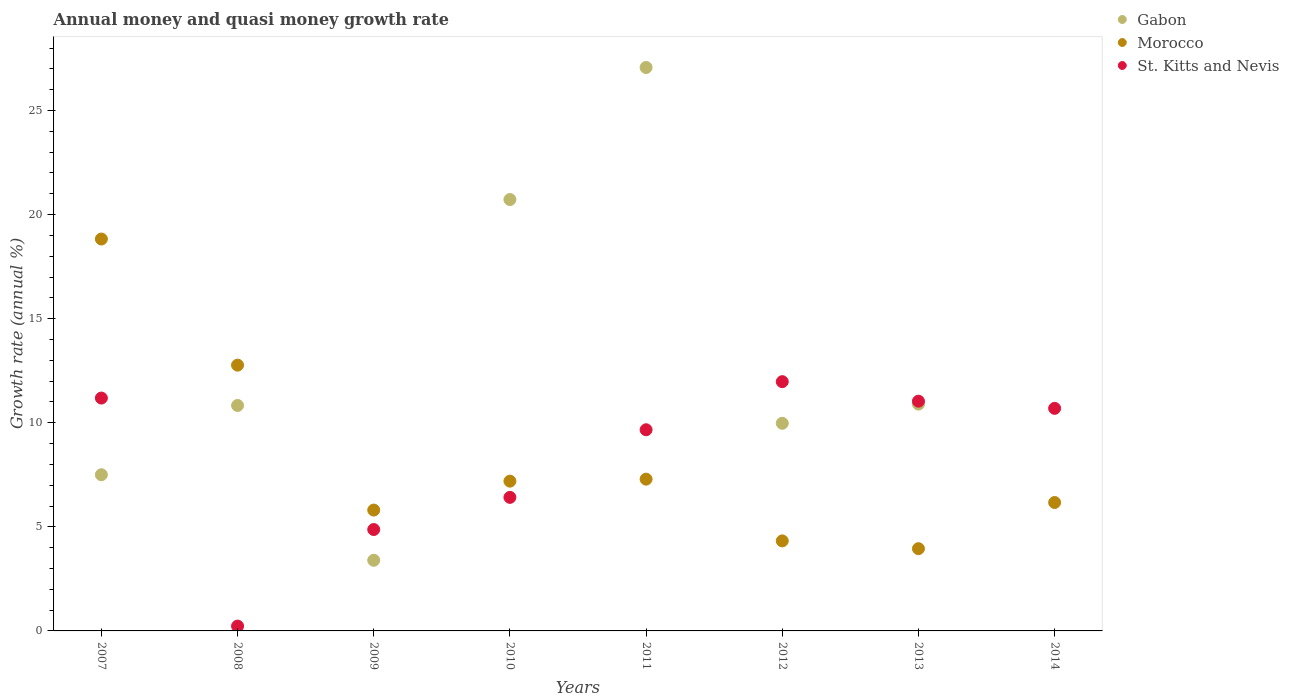How many different coloured dotlines are there?
Give a very brief answer. 3. What is the growth rate in St. Kitts and Nevis in 2014?
Make the answer very short. 10.69. Across all years, what is the maximum growth rate in Gabon?
Provide a short and direct response. 27.07. Across all years, what is the minimum growth rate in St. Kitts and Nevis?
Offer a very short reply. 0.23. What is the total growth rate in Gabon in the graph?
Offer a very short reply. 90.38. What is the difference between the growth rate in Morocco in 2011 and that in 2014?
Provide a short and direct response. 1.12. What is the difference between the growth rate in Gabon in 2013 and the growth rate in Morocco in 2007?
Offer a very short reply. -7.93. What is the average growth rate in Morocco per year?
Keep it short and to the point. 8.29. In the year 2012, what is the difference between the growth rate in Morocco and growth rate in Gabon?
Provide a short and direct response. -5.65. What is the ratio of the growth rate in Morocco in 2010 to that in 2011?
Keep it short and to the point. 0.99. Is the growth rate in Gabon in 2008 less than that in 2009?
Offer a very short reply. No. Is the difference between the growth rate in Morocco in 2012 and 2013 greater than the difference between the growth rate in Gabon in 2012 and 2013?
Provide a succinct answer. Yes. What is the difference between the highest and the second highest growth rate in Gabon?
Ensure brevity in your answer.  6.34. What is the difference between the highest and the lowest growth rate in Morocco?
Keep it short and to the point. 14.87. Is the sum of the growth rate in Gabon in 2008 and 2010 greater than the maximum growth rate in St. Kitts and Nevis across all years?
Offer a terse response. Yes. Is it the case that in every year, the sum of the growth rate in Gabon and growth rate in Morocco  is greater than the growth rate in St. Kitts and Nevis?
Provide a succinct answer. No. Does the growth rate in St. Kitts and Nevis monotonically increase over the years?
Provide a succinct answer. No. Is the growth rate in St. Kitts and Nevis strictly greater than the growth rate in Morocco over the years?
Ensure brevity in your answer.  No. Is the growth rate in St. Kitts and Nevis strictly less than the growth rate in Gabon over the years?
Your answer should be compact. No. How many dotlines are there?
Your answer should be very brief. 3. How many years are there in the graph?
Your answer should be very brief. 8. Are the values on the major ticks of Y-axis written in scientific E-notation?
Keep it short and to the point. No. How many legend labels are there?
Offer a terse response. 3. How are the legend labels stacked?
Ensure brevity in your answer.  Vertical. What is the title of the graph?
Ensure brevity in your answer.  Annual money and quasi money growth rate. Does "Croatia" appear as one of the legend labels in the graph?
Offer a very short reply. No. What is the label or title of the X-axis?
Offer a terse response. Years. What is the label or title of the Y-axis?
Keep it short and to the point. Growth rate (annual %). What is the Growth rate (annual %) in Gabon in 2007?
Provide a short and direct response. 7.5. What is the Growth rate (annual %) in Morocco in 2007?
Offer a terse response. 18.83. What is the Growth rate (annual %) of St. Kitts and Nevis in 2007?
Give a very brief answer. 11.19. What is the Growth rate (annual %) of Gabon in 2008?
Give a very brief answer. 10.83. What is the Growth rate (annual %) in Morocco in 2008?
Your response must be concise. 12.77. What is the Growth rate (annual %) in St. Kitts and Nevis in 2008?
Provide a short and direct response. 0.23. What is the Growth rate (annual %) of Gabon in 2009?
Offer a very short reply. 3.39. What is the Growth rate (annual %) of Morocco in 2009?
Make the answer very short. 5.8. What is the Growth rate (annual %) of St. Kitts and Nevis in 2009?
Provide a succinct answer. 4.87. What is the Growth rate (annual %) of Gabon in 2010?
Keep it short and to the point. 20.72. What is the Growth rate (annual %) of Morocco in 2010?
Your answer should be compact. 7.19. What is the Growth rate (annual %) in St. Kitts and Nevis in 2010?
Give a very brief answer. 6.41. What is the Growth rate (annual %) in Gabon in 2011?
Keep it short and to the point. 27.07. What is the Growth rate (annual %) of Morocco in 2011?
Provide a succinct answer. 7.29. What is the Growth rate (annual %) of St. Kitts and Nevis in 2011?
Your answer should be very brief. 9.66. What is the Growth rate (annual %) of Gabon in 2012?
Your answer should be compact. 9.97. What is the Growth rate (annual %) of Morocco in 2012?
Give a very brief answer. 4.32. What is the Growth rate (annual %) of St. Kitts and Nevis in 2012?
Your answer should be compact. 11.97. What is the Growth rate (annual %) in Gabon in 2013?
Make the answer very short. 10.9. What is the Growth rate (annual %) of Morocco in 2013?
Ensure brevity in your answer.  3.95. What is the Growth rate (annual %) of St. Kitts and Nevis in 2013?
Offer a very short reply. 11.04. What is the Growth rate (annual %) in Morocco in 2014?
Provide a succinct answer. 6.17. What is the Growth rate (annual %) in St. Kitts and Nevis in 2014?
Your answer should be compact. 10.69. Across all years, what is the maximum Growth rate (annual %) of Gabon?
Provide a short and direct response. 27.07. Across all years, what is the maximum Growth rate (annual %) of Morocco?
Ensure brevity in your answer.  18.83. Across all years, what is the maximum Growth rate (annual %) of St. Kitts and Nevis?
Keep it short and to the point. 11.97. Across all years, what is the minimum Growth rate (annual %) in Gabon?
Provide a succinct answer. 0. Across all years, what is the minimum Growth rate (annual %) in Morocco?
Offer a terse response. 3.95. Across all years, what is the minimum Growth rate (annual %) in St. Kitts and Nevis?
Your answer should be very brief. 0.23. What is the total Growth rate (annual %) of Gabon in the graph?
Offer a terse response. 90.38. What is the total Growth rate (annual %) of Morocco in the graph?
Your answer should be compact. 66.33. What is the total Growth rate (annual %) of St. Kitts and Nevis in the graph?
Provide a succinct answer. 66.07. What is the difference between the Growth rate (annual %) of Gabon in 2007 and that in 2008?
Your answer should be very brief. -3.33. What is the difference between the Growth rate (annual %) in Morocco in 2007 and that in 2008?
Keep it short and to the point. 6.06. What is the difference between the Growth rate (annual %) in St. Kitts and Nevis in 2007 and that in 2008?
Your response must be concise. 10.95. What is the difference between the Growth rate (annual %) in Gabon in 2007 and that in 2009?
Your answer should be very brief. 4.11. What is the difference between the Growth rate (annual %) in Morocco in 2007 and that in 2009?
Provide a succinct answer. 13.02. What is the difference between the Growth rate (annual %) of St. Kitts and Nevis in 2007 and that in 2009?
Ensure brevity in your answer.  6.31. What is the difference between the Growth rate (annual %) in Gabon in 2007 and that in 2010?
Ensure brevity in your answer.  -13.22. What is the difference between the Growth rate (annual %) in Morocco in 2007 and that in 2010?
Give a very brief answer. 11.63. What is the difference between the Growth rate (annual %) of St. Kitts and Nevis in 2007 and that in 2010?
Ensure brevity in your answer.  4.77. What is the difference between the Growth rate (annual %) in Gabon in 2007 and that in 2011?
Provide a short and direct response. -19.56. What is the difference between the Growth rate (annual %) in Morocco in 2007 and that in 2011?
Your response must be concise. 11.53. What is the difference between the Growth rate (annual %) in St. Kitts and Nevis in 2007 and that in 2011?
Your answer should be compact. 1.52. What is the difference between the Growth rate (annual %) of Gabon in 2007 and that in 2012?
Your answer should be very brief. -2.47. What is the difference between the Growth rate (annual %) in Morocco in 2007 and that in 2012?
Your response must be concise. 14.5. What is the difference between the Growth rate (annual %) in St. Kitts and Nevis in 2007 and that in 2012?
Keep it short and to the point. -0.79. What is the difference between the Growth rate (annual %) of Gabon in 2007 and that in 2013?
Ensure brevity in your answer.  -3.39. What is the difference between the Growth rate (annual %) of Morocco in 2007 and that in 2013?
Offer a very short reply. 14.87. What is the difference between the Growth rate (annual %) in St. Kitts and Nevis in 2007 and that in 2013?
Your response must be concise. 0.15. What is the difference between the Growth rate (annual %) of Morocco in 2007 and that in 2014?
Provide a succinct answer. 12.66. What is the difference between the Growth rate (annual %) of St. Kitts and Nevis in 2007 and that in 2014?
Make the answer very short. 0.49. What is the difference between the Growth rate (annual %) of Gabon in 2008 and that in 2009?
Offer a terse response. 7.44. What is the difference between the Growth rate (annual %) of Morocco in 2008 and that in 2009?
Make the answer very short. 6.96. What is the difference between the Growth rate (annual %) in St. Kitts and Nevis in 2008 and that in 2009?
Your response must be concise. -4.64. What is the difference between the Growth rate (annual %) in Gabon in 2008 and that in 2010?
Your answer should be very brief. -9.89. What is the difference between the Growth rate (annual %) in Morocco in 2008 and that in 2010?
Offer a very short reply. 5.57. What is the difference between the Growth rate (annual %) of St. Kitts and Nevis in 2008 and that in 2010?
Your response must be concise. -6.18. What is the difference between the Growth rate (annual %) of Gabon in 2008 and that in 2011?
Keep it short and to the point. -16.23. What is the difference between the Growth rate (annual %) of Morocco in 2008 and that in 2011?
Offer a very short reply. 5.48. What is the difference between the Growth rate (annual %) of St. Kitts and Nevis in 2008 and that in 2011?
Give a very brief answer. -9.43. What is the difference between the Growth rate (annual %) of Gabon in 2008 and that in 2012?
Offer a very short reply. 0.86. What is the difference between the Growth rate (annual %) in Morocco in 2008 and that in 2012?
Make the answer very short. 8.44. What is the difference between the Growth rate (annual %) in St. Kitts and Nevis in 2008 and that in 2012?
Keep it short and to the point. -11.74. What is the difference between the Growth rate (annual %) in Gabon in 2008 and that in 2013?
Your response must be concise. -0.07. What is the difference between the Growth rate (annual %) in Morocco in 2008 and that in 2013?
Your response must be concise. 8.82. What is the difference between the Growth rate (annual %) of St. Kitts and Nevis in 2008 and that in 2013?
Ensure brevity in your answer.  -10.8. What is the difference between the Growth rate (annual %) in Morocco in 2008 and that in 2014?
Offer a very short reply. 6.6. What is the difference between the Growth rate (annual %) in St. Kitts and Nevis in 2008 and that in 2014?
Make the answer very short. -10.46. What is the difference between the Growth rate (annual %) in Gabon in 2009 and that in 2010?
Offer a terse response. -17.33. What is the difference between the Growth rate (annual %) in Morocco in 2009 and that in 2010?
Provide a succinct answer. -1.39. What is the difference between the Growth rate (annual %) of St. Kitts and Nevis in 2009 and that in 2010?
Ensure brevity in your answer.  -1.54. What is the difference between the Growth rate (annual %) of Gabon in 2009 and that in 2011?
Keep it short and to the point. -23.67. What is the difference between the Growth rate (annual %) in Morocco in 2009 and that in 2011?
Provide a succinct answer. -1.49. What is the difference between the Growth rate (annual %) of St. Kitts and Nevis in 2009 and that in 2011?
Provide a short and direct response. -4.79. What is the difference between the Growth rate (annual %) of Gabon in 2009 and that in 2012?
Your response must be concise. -6.58. What is the difference between the Growth rate (annual %) in Morocco in 2009 and that in 2012?
Offer a terse response. 1.48. What is the difference between the Growth rate (annual %) of St. Kitts and Nevis in 2009 and that in 2012?
Keep it short and to the point. -7.1. What is the difference between the Growth rate (annual %) of Gabon in 2009 and that in 2013?
Ensure brevity in your answer.  -7.5. What is the difference between the Growth rate (annual %) in Morocco in 2009 and that in 2013?
Offer a terse response. 1.85. What is the difference between the Growth rate (annual %) in St. Kitts and Nevis in 2009 and that in 2013?
Your response must be concise. -6.17. What is the difference between the Growth rate (annual %) in Morocco in 2009 and that in 2014?
Offer a very short reply. -0.36. What is the difference between the Growth rate (annual %) of St. Kitts and Nevis in 2009 and that in 2014?
Make the answer very short. -5.82. What is the difference between the Growth rate (annual %) in Gabon in 2010 and that in 2011?
Provide a succinct answer. -6.34. What is the difference between the Growth rate (annual %) of Morocco in 2010 and that in 2011?
Keep it short and to the point. -0.1. What is the difference between the Growth rate (annual %) of St. Kitts and Nevis in 2010 and that in 2011?
Ensure brevity in your answer.  -3.25. What is the difference between the Growth rate (annual %) of Gabon in 2010 and that in 2012?
Make the answer very short. 10.75. What is the difference between the Growth rate (annual %) of Morocco in 2010 and that in 2012?
Offer a very short reply. 2.87. What is the difference between the Growth rate (annual %) in St. Kitts and Nevis in 2010 and that in 2012?
Make the answer very short. -5.56. What is the difference between the Growth rate (annual %) in Gabon in 2010 and that in 2013?
Offer a terse response. 9.83. What is the difference between the Growth rate (annual %) in Morocco in 2010 and that in 2013?
Make the answer very short. 3.24. What is the difference between the Growth rate (annual %) of St. Kitts and Nevis in 2010 and that in 2013?
Provide a short and direct response. -4.62. What is the difference between the Growth rate (annual %) of Morocco in 2010 and that in 2014?
Provide a short and direct response. 1.03. What is the difference between the Growth rate (annual %) of St. Kitts and Nevis in 2010 and that in 2014?
Give a very brief answer. -4.28. What is the difference between the Growth rate (annual %) of Gabon in 2011 and that in 2012?
Offer a very short reply. 17.09. What is the difference between the Growth rate (annual %) in Morocco in 2011 and that in 2012?
Offer a very short reply. 2.97. What is the difference between the Growth rate (annual %) of St. Kitts and Nevis in 2011 and that in 2012?
Give a very brief answer. -2.31. What is the difference between the Growth rate (annual %) of Gabon in 2011 and that in 2013?
Provide a succinct answer. 16.17. What is the difference between the Growth rate (annual %) in Morocco in 2011 and that in 2013?
Make the answer very short. 3.34. What is the difference between the Growth rate (annual %) of St. Kitts and Nevis in 2011 and that in 2013?
Offer a very short reply. -1.37. What is the difference between the Growth rate (annual %) of Morocco in 2011 and that in 2014?
Provide a succinct answer. 1.12. What is the difference between the Growth rate (annual %) of St. Kitts and Nevis in 2011 and that in 2014?
Your answer should be compact. -1.03. What is the difference between the Growth rate (annual %) of Gabon in 2012 and that in 2013?
Provide a short and direct response. -0.92. What is the difference between the Growth rate (annual %) of Morocco in 2012 and that in 2013?
Offer a terse response. 0.37. What is the difference between the Growth rate (annual %) of St. Kitts and Nevis in 2012 and that in 2013?
Provide a short and direct response. 0.94. What is the difference between the Growth rate (annual %) of Morocco in 2012 and that in 2014?
Make the answer very short. -1.84. What is the difference between the Growth rate (annual %) of St. Kitts and Nevis in 2012 and that in 2014?
Make the answer very short. 1.28. What is the difference between the Growth rate (annual %) of Morocco in 2013 and that in 2014?
Offer a very short reply. -2.22. What is the difference between the Growth rate (annual %) of St. Kitts and Nevis in 2013 and that in 2014?
Your response must be concise. 0.34. What is the difference between the Growth rate (annual %) in Gabon in 2007 and the Growth rate (annual %) in Morocco in 2008?
Ensure brevity in your answer.  -5.27. What is the difference between the Growth rate (annual %) in Gabon in 2007 and the Growth rate (annual %) in St. Kitts and Nevis in 2008?
Make the answer very short. 7.27. What is the difference between the Growth rate (annual %) of Morocco in 2007 and the Growth rate (annual %) of St. Kitts and Nevis in 2008?
Your response must be concise. 18.59. What is the difference between the Growth rate (annual %) in Gabon in 2007 and the Growth rate (annual %) in Morocco in 2009?
Ensure brevity in your answer.  1.7. What is the difference between the Growth rate (annual %) of Gabon in 2007 and the Growth rate (annual %) of St. Kitts and Nevis in 2009?
Offer a terse response. 2.63. What is the difference between the Growth rate (annual %) of Morocco in 2007 and the Growth rate (annual %) of St. Kitts and Nevis in 2009?
Provide a short and direct response. 13.95. What is the difference between the Growth rate (annual %) of Gabon in 2007 and the Growth rate (annual %) of Morocco in 2010?
Provide a succinct answer. 0.31. What is the difference between the Growth rate (annual %) in Gabon in 2007 and the Growth rate (annual %) in St. Kitts and Nevis in 2010?
Ensure brevity in your answer.  1.09. What is the difference between the Growth rate (annual %) in Morocco in 2007 and the Growth rate (annual %) in St. Kitts and Nevis in 2010?
Your answer should be very brief. 12.41. What is the difference between the Growth rate (annual %) of Gabon in 2007 and the Growth rate (annual %) of Morocco in 2011?
Your answer should be very brief. 0.21. What is the difference between the Growth rate (annual %) in Gabon in 2007 and the Growth rate (annual %) in St. Kitts and Nevis in 2011?
Your response must be concise. -2.16. What is the difference between the Growth rate (annual %) in Morocco in 2007 and the Growth rate (annual %) in St. Kitts and Nevis in 2011?
Offer a very short reply. 9.16. What is the difference between the Growth rate (annual %) in Gabon in 2007 and the Growth rate (annual %) in Morocco in 2012?
Your answer should be compact. 3.18. What is the difference between the Growth rate (annual %) of Gabon in 2007 and the Growth rate (annual %) of St. Kitts and Nevis in 2012?
Ensure brevity in your answer.  -4.47. What is the difference between the Growth rate (annual %) of Morocco in 2007 and the Growth rate (annual %) of St. Kitts and Nevis in 2012?
Make the answer very short. 6.85. What is the difference between the Growth rate (annual %) in Gabon in 2007 and the Growth rate (annual %) in Morocco in 2013?
Keep it short and to the point. 3.55. What is the difference between the Growth rate (annual %) in Gabon in 2007 and the Growth rate (annual %) in St. Kitts and Nevis in 2013?
Offer a very short reply. -3.53. What is the difference between the Growth rate (annual %) of Morocco in 2007 and the Growth rate (annual %) of St. Kitts and Nevis in 2013?
Keep it short and to the point. 7.79. What is the difference between the Growth rate (annual %) of Gabon in 2007 and the Growth rate (annual %) of Morocco in 2014?
Your answer should be very brief. 1.33. What is the difference between the Growth rate (annual %) of Gabon in 2007 and the Growth rate (annual %) of St. Kitts and Nevis in 2014?
Your answer should be compact. -3.19. What is the difference between the Growth rate (annual %) in Morocco in 2007 and the Growth rate (annual %) in St. Kitts and Nevis in 2014?
Offer a terse response. 8.13. What is the difference between the Growth rate (annual %) in Gabon in 2008 and the Growth rate (annual %) in Morocco in 2009?
Offer a very short reply. 5.03. What is the difference between the Growth rate (annual %) in Gabon in 2008 and the Growth rate (annual %) in St. Kitts and Nevis in 2009?
Provide a short and direct response. 5.96. What is the difference between the Growth rate (annual %) of Morocco in 2008 and the Growth rate (annual %) of St. Kitts and Nevis in 2009?
Offer a terse response. 7.9. What is the difference between the Growth rate (annual %) in Gabon in 2008 and the Growth rate (annual %) in Morocco in 2010?
Ensure brevity in your answer.  3.64. What is the difference between the Growth rate (annual %) of Gabon in 2008 and the Growth rate (annual %) of St. Kitts and Nevis in 2010?
Your response must be concise. 4.42. What is the difference between the Growth rate (annual %) of Morocco in 2008 and the Growth rate (annual %) of St. Kitts and Nevis in 2010?
Ensure brevity in your answer.  6.35. What is the difference between the Growth rate (annual %) in Gabon in 2008 and the Growth rate (annual %) in Morocco in 2011?
Make the answer very short. 3.54. What is the difference between the Growth rate (annual %) of Gabon in 2008 and the Growth rate (annual %) of St. Kitts and Nevis in 2011?
Keep it short and to the point. 1.17. What is the difference between the Growth rate (annual %) in Morocco in 2008 and the Growth rate (annual %) in St. Kitts and Nevis in 2011?
Keep it short and to the point. 3.1. What is the difference between the Growth rate (annual %) in Gabon in 2008 and the Growth rate (annual %) in Morocco in 2012?
Provide a short and direct response. 6.51. What is the difference between the Growth rate (annual %) in Gabon in 2008 and the Growth rate (annual %) in St. Kitts and Nevis in 2012?
Provide a short and direct response. -1.14. What is the difference between the Growth rate (annual %) of Morocco in 2008 and the Growth rate (annual %) of St. Kitts and Nevis in 2012?
Keep it short and to the point. 0.79. What is the difference between the Growth rate (annual %) of Gabon in 2008 and the Growth rate (annual %) of Morocco in 2013?
Offer a very short reply. 6.88. What is the difference between the Growth rate (annual %) of Gabon in 2008 and the Growth rate (annual %) of St. Kitts and Nevis in 2013?
Offer a terse response. -0.21. What is the difference between the Growth rate (annual %) of Morocco in 2008 and the Growth rate (annual %) of St. Kitts and Nevis in 2013?
Give a very brief answer. 1.73. What is the difference between the Growth rate (annual %) of Gabon in 2008 and the Growth rate (annual %) of Morocco in 2014?
Your answer should be very brief. 4.66. What is the difference between the Growth rate (annual %) in Gabon in 2008 and the Growth rate (annual %) in St. Kitts and Nevis in 2014?
Provide a short and direct response. 0.14. What is the difference between the Growth rate (annual %) of Morocco in 2008 and the Growth rate (annual %) of St. Kitts and Nevis in 2014?
Make the answer very short. 2.08. What is the difference between the Growth rate (annual %) of Gabon in 2009 and the Growth rate (annual %) of Morocco in 2010?
Your answer should be compact. -3.8. What is the difference between the Growth rate (annual %) in Gabon in 2009 and the Growth rate (annual %) in St. Kitts and Nevis in 2010?
Offer a very short reply. -3.02. What is the difference between the Growth rate (annual %) of Morocco in 2009 and the Growth rate (annual %) of St. Kitts and Nevis in 2010?
Make the answer very short. -0.61. What is the difference between the Growth rate (annual %) of Gabon in 2009 and the Growth rate (annual %) of Morocco in 2011?
Your response must be concise. -3.9. What is the difference between the Growth rate (annual %) in Gabon in 2009 and the Growth rate (annual %) in St. Kitts and Nevis in 2011?
Make the answer very short. -6.27. What is the difference between the Growth rate (annual %) of Morocco in 2009 and the Growth rate (annual %) of St. Kitts and Nevis in 2011?
Make the answer very short. -3.86. What is the difference between the Growth rate (annual %) in Gabon in 2009 and the Growth rate (annual %) in Morocco in 2012?
Give a very brief answer. -0.93. What is the difference between the Growth rate (annual %) of Gabon in 2009 and the Growth rate (annual %) of St. Kitts and Nevis in 2012?
Ensure brevity in your answer.  -8.58. What is the difference between the Growth rate (annual %) in Morocco in 2009 and the Growth rate (annual %) in St. Kitts and Nevis in 2012?
Your answer should be very brief. -6.17. What is the difference between the Growth rate (annual %) in Gabon in 2009 and the Growth rate (annual %) in Morocco in 2013?
Your answer should be compact. -0.56. What is the difference between the Growth rate (annual %) in Gabon in 2009 and the Growth rate (annual %) in St. Kitts and Nevis in 2013?
Provide a succinct answer. -7.64. What is the difference between the Growth rate (annual %) in Morocco in 2009 and the Growth rate (annual %) in St. Kitts and Nevis in 2013?
Ensure brevity in your answer.  -5.23. What is the difference between the Growth rate (annual %) of Gabon in 2009 and the Growth rate (annual %) of Morocco in 2014?
Ensure brevity in your answer.  -2.78. What is the difference between the Growth rate (annual %) in Gabon in 2009 and the Growth rate (annual %) in St. Kitts and Nevis in 2014?
Provide a short and direct response. -7.3. What is the difference between the Growth rate (annual %) in Morocco in 2009 and the Growth rate (annual %) in St. Kitts and Nevis in 2014?
Your answer should be compact. -4.89. What is the difference between the Growth rate (annual %) of Gabon in 2010 and the Growth rate (annual %) of Morocco in 2011?
Offer a very short reply. 13.43. What is the difference between the Growth rate (annual %) of Gabon in 2010 and the Growth rate (annual %) of St. Kitts and Nevis in 2011?
Keep it short and to the point. 11.06. What is the difference between the Growth rate (annual %) of Morocco in 2010 and the Growth rate (annual %) of St. Kitts and Nevis in 2011?
Keep it short and to the point. -2.47. What is the difference between the Growth rate (annual %) of Gabon in 2010 and the Growth rate (annual %) of Morocco in 2012?
Offer a very short reply. 16.4. What is the difference between the Growth rate (annual %) in Gabon in 2010 and the Growth rate (annual %) in St. Kitts and Nevis in 2012?
Your response must be concise. 8.75. What is the difference between the Growth rate (annual %) in Morocco in 2010 and the Growth rate (annual %) in St. Kitts and Nevis in 2012?
Your answer should be very brief. -4.78. What is the difference between the Growth rate (annual %) in Gabon in 2010 and the Growth rate (annual %) in Morocco in 2013?
Provide a short and direct response. 16.77. What is the difference between the Growth rate (annual %) of Gabon in 2010 and the Growth rate (annual %) of St. Kitts and Nevis in 2013?
Your answer should be very brief. 9.69. What is the difference between the Growth rate (annual %) of Morocco in 2010 and the Growth rate (annual %) of St. Kitts and Nevis in 2013?
Keep it short and to the point. -3.84. What is the difference between the Growth rate (annual %) in Gabon in 2010 and the Growth rate (annual %) in Morocco in 2014?
Your response must be concise. 14.55. What is the difference between the Growth rate (annual %) of Gabon in 2010 and the Growth rate (annual %) of St. Kitts and Nevis in 2014?
Your answer should be compact. 10.03. What is the difference between the Growth rate (annual %) of Morocco in 2010 and the Growth rate (annual %) of St. Kitts and Nevis in 2014?
Your answer should be very brief. -3.5. What is the difference between the Growth rate (annual %) of Gabon in 2011 and the Growth rate (annual %) of Morocco in 2012?
Ensure brevity in your answer.  22.74. What is the difference between the Growth rate (annual %) in Gabon in 2011 and the Growth rate (annual %) in St. Kitts and Nevis in 2012?
Ensure brevity in your answer.  15.09. What is the difference between the Growth rate (annual %) of Morocco in 2011 and the Growth rate (annual %) of St. Kitts and Nevis in 2012?
Give a very brief answer. -4.68. What is the difference between the Growth rate (annual %) of Gabon in 2011 and the Growth rate (annual %) of Morocco in 2013?
Provide a succinct answer. 23.11. What is the difference between the Growth rate (annual %) of Gabon in 2011 and the Growth rate (annual %) of St. Kitts and Nevis in 2013?
Your answer should be compact. 16.03. What is the difference between the Growth rate (annual %) in Morocco in 2011 and the Growth rate (annual %) in St. Kitts and Nevis in 2013?
Give a very brief answer. -3.75. What is the difference between the Growth rate (annual %) of Gabon in 2011 and the Growth rate (annual %) of Morocco in 2014?
Your response must be concise. 20.9. What is the difference between the Growth rate (annual %) in Gabon in 2011 and the Growth rate (annual %) in St. Kitts and Nevis in 2014?
Your answer should be compact. 16.37. What is the difference between the Growth rate (annual %) of Morocco in 2011 and the Growth rate (annual %) of St. Kitts and Nevis in 2014?
Your answer should be compact. -3.4. What is the difference between the Growth rate (annual %) of Gabon in 2012 and the Growth rate (annual %) of Morocco in 2013?
Your answer should be compact. 6.02. What is the difference between the Growth rate (annual %) of Gabon in 2012 and the Growth rate (annual %) of St. Kitts and Nevis in 2013?
Provide a short and direct response. -1.06. What is the difference between the Growth rate (annual %) of Morocco in 2012 and the Growth rate (annual %) of St. Kitts and Nevis in 2013?
Make the answer very short. -6.71. What is the difference between the Growth rate (annual %) of Gabon in 2012 and the Growth rate (annual %) of Morocco in 2014?
Provide a short and direct response. 3.81. What is the difference between the Growth rate (annual %) of Gabon in 2012 and the Growth rate (annual %) of St. Kitts and Nevis in 2014?
Ensure brevity in your answer.  -0.72. What is the difference between the Growth rate (annual %) in Morocco in 2012 and the Growth rate (annual %) in St. Kitts and Nevis in 2014?
Make the answer very short. -6.37. What is the difference between the Growth rate (annual %) of Gabon in 2013 and the Growth rate (annual %) of Morocco in 2014?
Offer a terse response. 4.73. What is the difference between the Growth rate (annual %) in Gabon in 2013 and the Growth rate (annual %) in St. Kitts and Nevis in 2014?
Keep it short and to the point. 0.21. What is the difference between the Growth rate (annual %) in Morocco in 2013 and the Growth rate (annual %) in St. Kitts and Nevis in 2014?
Provide a succinct answer. -6.74. What is the average Growth rate (annual %) of Gabon per year?
Offer a terse response. 11.3. What is the average Growth rate (annual %) in Morocco per year?
Ensure brevity in your answer.  8.29. What is the average Growth rate (annual %) of St. Kitts and Nevis per year?
Provide a short and direct response. 8.26. In the year 2007, what is the difference between the Growth rate (annual %) of Gabon and Growth rate (annual %) of Morocco?
Provide a succinct answer. -11.32. In the year 2007, what is the difference between the Growth rate (annual %) of Gabon and Growth rate (annual %) of St. Kitts and Nevis?
Provide a short and direct response. -3.68. In the year 2007, what is the difference between the Growth rate (annual %) in Morocco and Growth rate (annual %) in St. Kitts and Nevis?
Make the answer very short. 7.64. In the year 2008, what is the difference between the Growth rate (annual %) in Gabon and Growth rate (annual %) in Morocco?
Ensure brevity in your answer.  -1.94. In the year 2008, what is the difference between the Growth rate (annual %) of Gabon and Growth rate (annual %) of St. Kitts and Nevis?
Offer a terse response. 10.6. In the year 2008, what is the difference between the Growth rate (annual %) in Morocco and Growth rate (annual %) in St. Kitts and Nevis?
Your answer should be compact. 12.53. In the year 2009, what is the difference between the Growth rate (annual %) of Gabon and Growth rate (annual %) of Morocco?
Keep it short and to the point. -2.41. In the year 2009, what is the difference between the Growth rate (annual %) of Gabon and Growth rate (annual %) of St. Kitts and Nevis?
Give a very brief answer. -1.48. In the year 2009, what is the difference between the Growth rate (annual %) in Morocco and Growth rate (annual %) in St. Kitts and Nevis?
Provide a succinct answer. 0.93. In the year 2010, what is the difference between the Growth rate (annual %) in Gabon and Growth rate (annual %) in Morocco?
Provide a succinct answer. 13.53. In the year 2010, what is the difference between the Growth rate (annual %) of Gabon and Growth rate (annual %) of St. Kitts and Nevis?
Keep it short and to the point. 14.31. In the year 2010, what is the difference between the Growth rate (annual %) in Morocco and Growth rate (annual %) in St. Kitts and Nevis?
Provide a succinct answer. 0.78. In the year 2011, what is the difference between the Growth rate (annual %) of Gabon and Growth rate (annual %) of Morocco?
Give a very brief answer. 19.77. In the year 2011, what is the difference between the Growth rate (annual %) in Gabon and Growth rate (annual %) in St. Kitts and Nevis?
Your answer should be very brief. 17.4. In the year 2011, what is the difference between the Growth rate (annual %) in Morocco and Growth rate (annual %) in St. Kitts and Nevis?
Ensure brevity in your answer.  -2.37. In the year 2012, what is the difference between the Growth rate (annual %) in Gabon and Growth rate (annual %) in Morocco?
Give a very brief answer. 5.65. In the year 2012, what is the difference between the Growth rate (annual %) in Gabon and Growth rate (annual %) in St. Kitts and Nevis?
Offer a terse response. -2. In the year 2012, what is the difference between the Growth rate (annual %) of Morocco and Growth rate (annual %) of St. Kitts and Nevis?
Your answer should be compact. -7.65. In the year 2013, what is the difference between the Growth rate (annual %) in Gabon and Growth rate (annual %) in Morocco?
Give a very brief answer. 6.95. In the year 2013, what is the difference between the Growth rate (annual %) of Gabon and Growth rate (annual %) of St. Kitts and Nevis?
Offer a very short reply. -0.14. In the year 2013, what is the difference between the Growth rate (annual %) in Morocco and Growth rate (annual %) in St. Kitts and Nevis?
Provide a succinct answer. -7.08. In the year 2014, what is the difference between the Growth rate (annual %) in Morocco and Growth rate (annual %) in St. Kitts and Nevis?
Make the answer very short. -4.52. What is the ratio of the Growth rate (annual %) in Gabon in 2007 to that in 2008?
Ensure brevity in your answer.  0.69. What is the ratio of the Growth rate (annual %) of Morocco in 2007 to that in 2008?
Give a very brief answer. 1.47. What is the ratio of the Growth rate (annual %) of St. Kitts and Nevis in 2007 to that in 2008?
Keep it short and to the point. 48.07. What is the ratio of the Growth rate (annual %) in Gabon in 2007 to that in 2009?
Your answer should be very brief. 2.21. What is the ratio of the Growth rate (annual %) of Morocco in 2007 to that in 2009?
Ensure brevity in your answer.  3.24. What is the ratio of the Growth rate (annual %) of St. Kitts and Nevis in 2007 to that in 2009?
Your response must be concise. 2.3. What is the ratio of the Growth rate (annual %) in Gabon in 2007 to that in 2010?
Your answer should be very brief. 0.36. What is the ratio of the Growth rate (annual %) in Morocco in 2007 to that in 2010?
Keep it short and to the point. 2.62. What is the ratio of the Growth rate (annual %) of St. Kitts and Nevis in 2007 to that in 2010?
Your response must be concise. 1.74. What is the ratio of the Growth rate (annual %) in Gabon in 2007 to that in 2011?
Make the answer very short. 0.28. What is the ratio of the Growth rate (annual %) in Morocco in 2007 to that in 2011?
Provide a succinct answer. 2.58. What is the ratio of the Growth rate (annual %) in St. Kitts and Nevis in 2007 to that in 2011?
Offer a terse response. 1.16. What is the ratio of the Growth rate (annual %) of Gabon in 2007 to that in 2012?
Keep it short and to the point. 0.75. What is the ratio of the Growth rate (annual %) in Morocco in 2007 to that in 2012?
Your answer should be compact. 4.35. What is the ratio of the Growth rate (annual %) in St. Kitts and Nevis in 2007 to that in 2012?
Give a very brief answer. 0.93. What is the ratio of the Growth rate (annual %) in Gabon in 2007 to that in 2013?
Offer a very short reply. 0.69. What is the ratio of the Growth rate (annual %) of Morocco in 2007 to that in 2013?
Give a very brief answer. 4.76. What is the ratio of the Growth rate (annual %) of St. Kitts and Nevis in 2007 to that in 2013?
Your response must be concise. 1.01. What is the ratio of the Growth rate (annual %) in Morocco in 2007 to that in 2014?
Offer a very short reply. 3.05. What is the ratio of the Growth rate (annual %) of St. Kitts and Nevis in 2007 to that in 2014?
Provide a short and direct response. 1.05. What is the ratio of the Growth rate (annual %) of Gabon in 2008 to that in 2009?
Your answer should be compact. 3.19. What is the ratio of the Growth rate (annual %) in Morocco in 2008 to that in 2009?
Provide a succinct answer. 2.2. What is the ratio of the Growth rate (annual %) in St. Kitts and Nevis in 2008 to that in 2009?
Your response must be concise. 0.05. What is the ratio of the Growth rate (annual %) of Gabon in 2008 to that in 2010?
Ensure brevity in your answer.  0.52. What is the ratio of the Growth rate (annual %) of Morocco in 2008 to that in 2010?
Make the answer very short. 1.77. What is the ratio of the Growth rate (annual %) of St. Kitts and Nevis in 2008 to that in 2010?
Provide a succinct answer. 0.04. What is the ratio of the Growth rate (annual %) of Gabon in 2008 to that in 2011?
Ensure brevity in your answer.  0.4. What is the ratio of the Growth rate (annual %) in Morocco in 2008 to that in 2011?
Offer a terse response. 1.75. What is the ratio of the Growth rate (annual %) of St. Kitts and Nevis in 2008 to that in 2011?
Ensure brevity in your answer.  0.02. What is the ratio of the Growth rate (annual %) in Gabon in 2008 to that in 2012?
Your answer should be very brief. 1.09. What is the ratio of the Growth rate (annual %) in Morocco in 2008 to that in 2012?
Offer a terse response. 2.95. What is the ratio of the Growth rate (annual %) in St. Kitts and Nevis in 2008 to that in 2012?
Provide a succinct answer. 0.02. What is the ratio of the Growth rate (annual %) of Gabon in 2008 to that in 2013?
Offer a very short reply. 0.99. What is the ratio of the Growth rate (annual %) in Morocco in 2008 to that in 2013?
Ensure brevity in your answer.  3.23. What is the ratio of the Growth rate (annual %) of St. Kitts and Nevis in 2008 to that in 2013?
Your response must be concise. 0.02. What is the ratio of the Growth rate (annual %) in Morocco in 2008 to that in 2014?
Provide a short and direct response. 2.07. What is the ratio of the Growth rate (annual %) in St. Kitts and Nevis in 2008 to that in 2014?
Provide a short and direct response. 0.02. What is the ratio of the Growth rate (annual %) of Gabon in 2009 to that in 2010?
Your answer should be very brief. 0.16. What is the ratio of the Growth rate (annual %) in Morocco in 2009 to that in 2010?
Provide a short and direct response. 0.81. What is the ratio of the Growth rate (annual %) in St. Kitts and Nevis in 2009 to that in 2010?
Keep it short and to the point. 0.76. What is the ratio of the Growth rate (annual %) of Gabon in 2009 to that in 2011?
Keep it short and to the point. 0.13. What is the ratio of the Growth rate (annual %) of Morocco in 2009 to that in 2011?
Make the answer very short. 0.8. What is the ratio of the Growth rate (annual %) of St. Kitts and Nevis in 2009 to that in 2011?
Your response must be concise. 0.5. What is the ratio of the Growth rate (annual %) of Gabon in 2009 to that in 2012?
Give a very brief answer. 0.34. What is the ratio of the Growth rate (annual %) in Morocco in 2009 to that in 2012?
Your answer should be compact. 1.34. What is the ratio of the Growth rate (annual %) in St. Kitts and Nevis in 2009 to that in 2012?
Offer a very short reply. 0.41. What is the ratio of the Growth rate (annual %) of Gabon in 2009 to that in 2013?
Provide a succinct answer. 0.31. What is the ratio of the Growth rate (annual %) of Morocco in 2009 to that in 2013?
Your response must be concise. 1.47. What is the ratio of the Growth rate (annual %) of St. Kitts and Nevis in 2009 to that in 2013?
Keep it short and to the point. 0.44. What is the ratio of the Growth rate (annual %) of Morocco in 2009 to that in 2014?
Make the answer very short. 0.94. What is the ratio of the Growth rate (annual %) in St. Kitts and Nevis in 2009 to that in 2014?
Give a very brief answer. 0.46. What is the ratio of the Growth rate (annual %) of Gabon in 2010 to that in 2011?
Ensure brevity in your answer.  0.77. What is the ratio of the Growth rate (annual %) in Morocco in 2010 to that in 2011?
Ensure brevity in your answer.  0.99. What is the ratio of the Growth rate (annual %) of St. Kitts and Nevis in 2010 to that in 2011?
Offer a very short reply. 0.66. What is the ratio of the Growth rate (annual %) of Gabon in 2010 to that in 2012?
Give a very brief answer. 2.08. What is the ratio of the Growth rate (annual %) of Morocco in 2010 to that in 2012?
Make the answer very short. 1.66. What is the ratio of the Growth rate (annual %) in St. Kitts and Nevis in 2010 to that in 2012?
Provide a short and direct response. 0.54. What is the ratio of the Growth rate (annual %) in Gabon in 2010 to that in 2013?
Offer a terse response. 1.9. What is the ratio of the Growth rate (annual %) of Morocco in 2010 to that in 2013?
Offer a terse response. 1.82. What is the ratio of the Growth rate (annual %) of St. Kitts and Nevis in 2010 to that in 2013?
Keep it short and to the point. 0.58. What is the ratio of the Growth rate (annual %) of Morocco in 2010 to that in 2014?
Offer a terse response. 1.17. What is the ratio of the Growth rate (annual %) of St. Kitts and Nevis in 2010 to that in 2014?
Your response must be concise. 0.6. What is the ratio of the Growth rate (annual %) of Gabon in 2011 to that in 2012?
Provide a succinct answer. 2.71. What is the ratio of the Growth rate (annual %) of Morocco in 2011 to that in 2012?
Give a very brief answer. 1.69. What is the ratio of the Growth rate (annual %) of St. Kitts and Nevis in 2011 to that in 2012?
Your response must be concise. 0.81. What is the ratio of the Growth rate (annual %) of Gabon in 2011 to that in 2013?
Give a very brief answer. 2.48. What is the ratio of the Growth rate (annual %) in Morocco in 2011 to that in 2013?
Give a very brief answer. 1.85. What is the ratio of the Growth rate (annual %) in St. Kitts and Nevis in 2011 to that in 2013?
Keep it short and to the point. 0.88. What is the ratio of the Growth rate (annual %) of Morocco in 2011 to that in 2014?
Keep it short and to the point. 1.18. What is the ratio of the Growth rate (annual %) in St. Kitts and Nevis in 2011 to that in 2014?
Your answer should be compact. 0.9. What is the ratio of the Growth rate (annual %) in Gabon in 2012 to that in 2013?
Offer a very short reply. 0.92. What is the ratio of the Growth rate (annual %) of Morocco in 2012 to that in 2013?
Provide a succinct answer. 1.09. What is the ratio of the Growth rate (annual %) of St. Kitts and Nevis in 2012 to that in 2013?
Provide a succinct answer. 1.08. What is the ratio of the Growth rate (annual %) in Morocco in 2012 to that in 2014?
Ensure brevity in your answer.  0.7. What is the ratio of the Growth rate (annual %) in St. Kitts and Nevis in 2012 to that in 2014?
Give a very brief answer. 1.12. What is the ratio of the Growth rate (annual %) of Morocco in 2013 to that in 2014?
Offer a terse response. 0.64. What is the ratio of the Growth rate (annual %) of St. Kitts and Nevis in 2013 to that in 2014?
Provide a short and direct response. 1.03. What is the difference between the highest and the second highest Growth rate (annual %) in Gabon?
Make the answer very short. 6.34. What is the difference between the highest and the second highest Growth rate (annual %) of Morocco?
Your response must be concise. 6.06. What is the difference between the highest and the second highest Growth rate (annual %) of St. Kitts and Nevis?
Provide a short and direct response. 0.79. What is the difference between the highest and the lowest Growth rate (annual %) of Gabon?
Your answer should be very brief. 27.07. What is the difference between the highest and the lowest Growth rate (annual %) of Morocco?
Provide a succinct answer. 14.87. What is the difference between the highest and the lowest Growth rate (annual %) in St. Kitts and Nevis?
Make the answer very short. 11.74. 